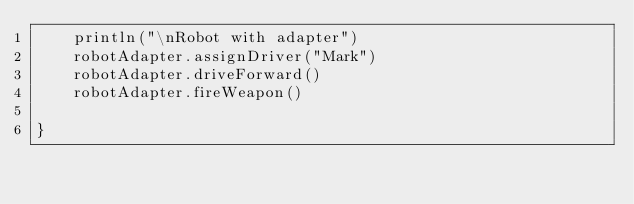<code> <loc_0><loc_0><loc_500><loc_500><_Kotlin_>    println("\nRobot with adapter")
    robotAdapter.assignDriver("Mark")
    robotAdapter.driveForward()
    robotAdapter.fireWeapon()

}</code> 